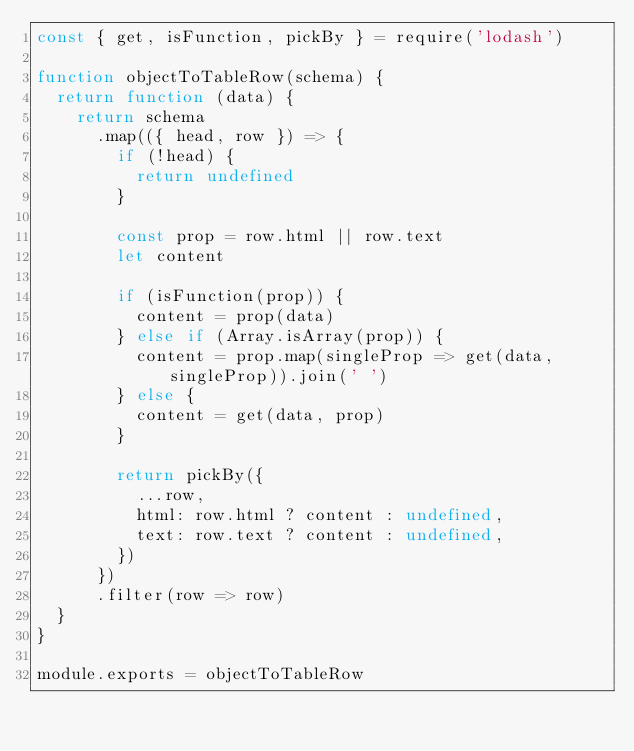Convert code to text. <code><loc_0><loc_0><loc_500><loc_500><_JavaScript_>const { get, isFunction, pickBy } = require('lodash')

function objectToTableRow(schema) {
  return function (data) {
    return schema
      .map(({ head, row }) => {
        if (!head) {
          return undefined
        }

        const prop = row.html || row.text
        let content

        if (isFunction(prop)) {
          content = prop(data)
        } else if (Array.isArray(prop)) {
          content = prop.map(singleProp => get(data, singleProp)).join(' ')
        } else {
          content = get(data, prop)
        }

        return pickBy({
          ...row,
          html: row.html ? content : undefined,
          text: row.text ? content : undefined,
        })
      })
      .filter(row => row)
  }
}

module.exports = objectToTableRow
</code> 